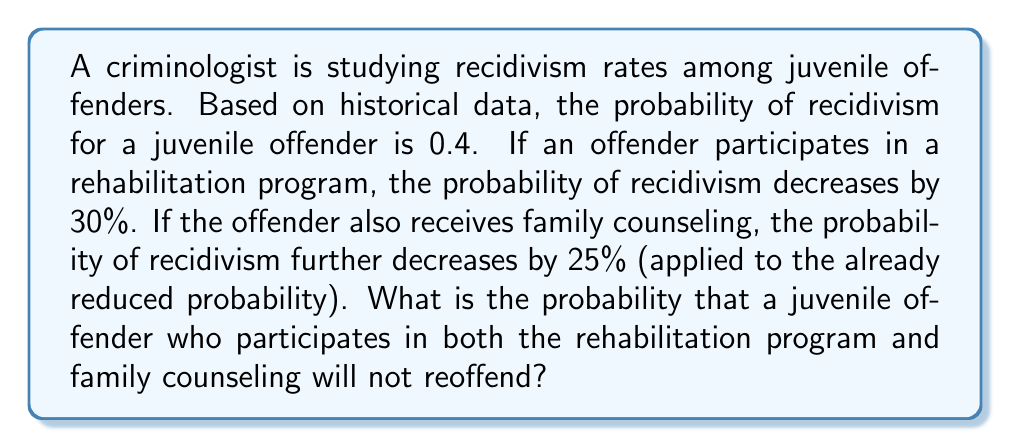What is the answer to this math problem? Let's approach this step-by-step:

1) Initial probability of recidivism: $p_1 = 0.4$

2) After rehabilitation program:
   The probability decreases by 30%, so the new probability is:
   $p_2 = p_1 \cdot (1 - 0.3) = 0.4 \cdot 0.7 = 0.28$

3) After family counseling:
   The probability further decreases by 25% of the already reduced probability:
   $p_3 = p_2 \cdot (1 - 0.25) = 0.28 \cdot 0.75 = 0.21$

4) The question asks for the probability of not reoffending. This is the complement of the probability of reoffending:
   $P(\text{not reoffending}) = 1 - P(\text{reoffending}) = 1 - p_3 = 1 - 0.21 = 0.79$

Therefore, the probability that a juvenile offender who participates in both the rehabilitation program and family counseling will not reoffend is 0.79 or 79%.
Answer: 0.79 